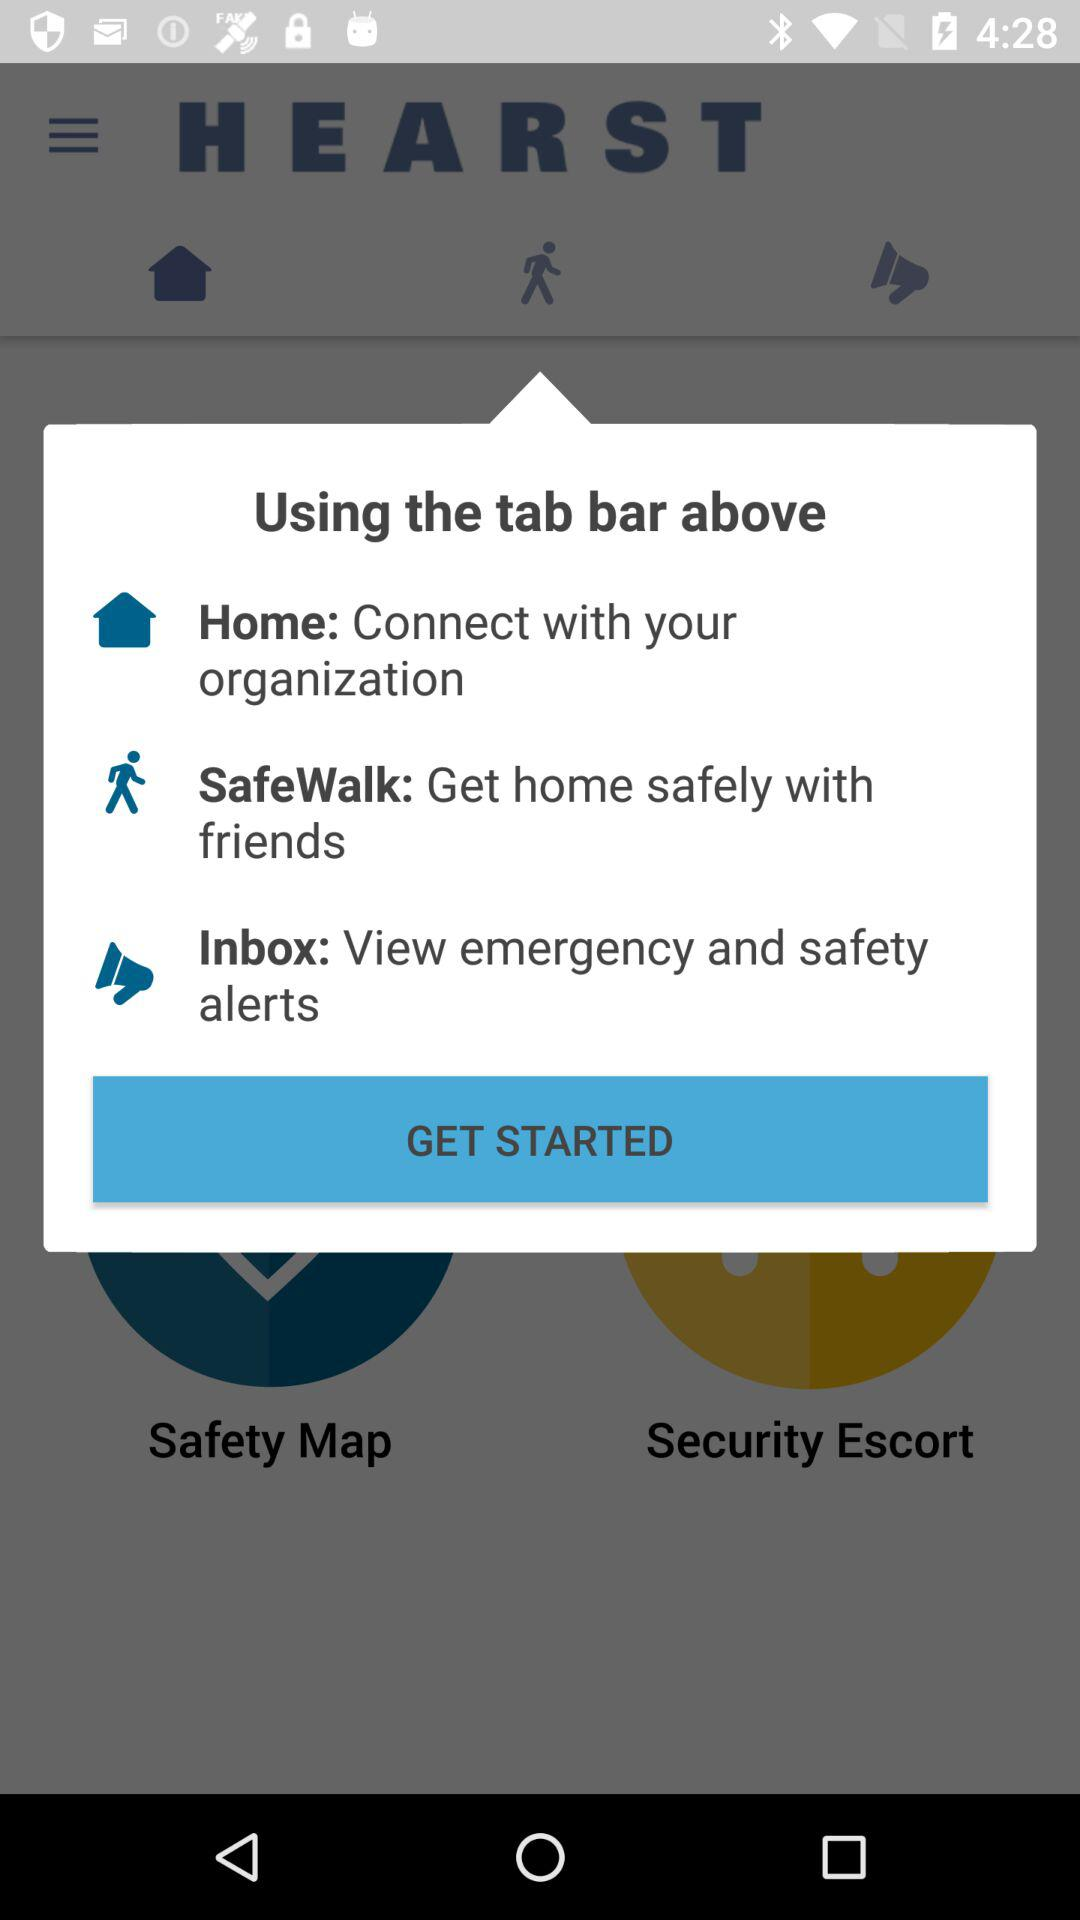What is the name of the application? The name of the application is "HEARST". 